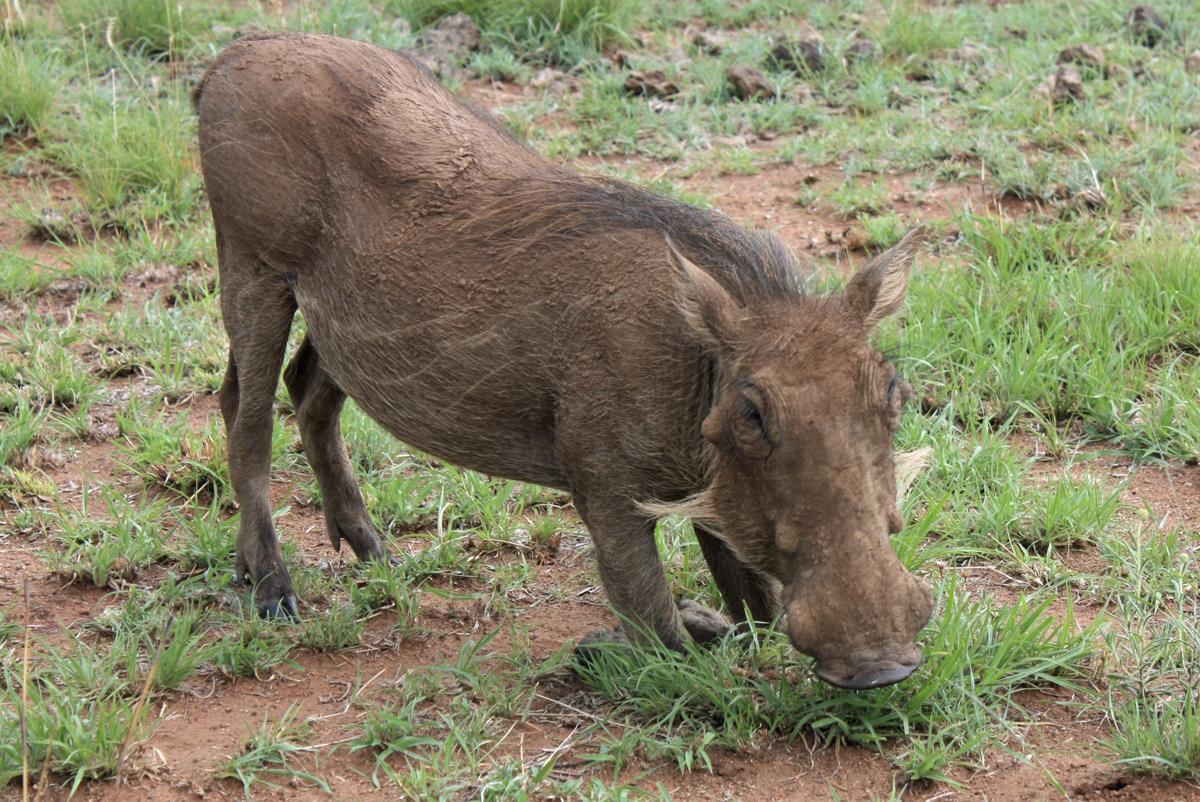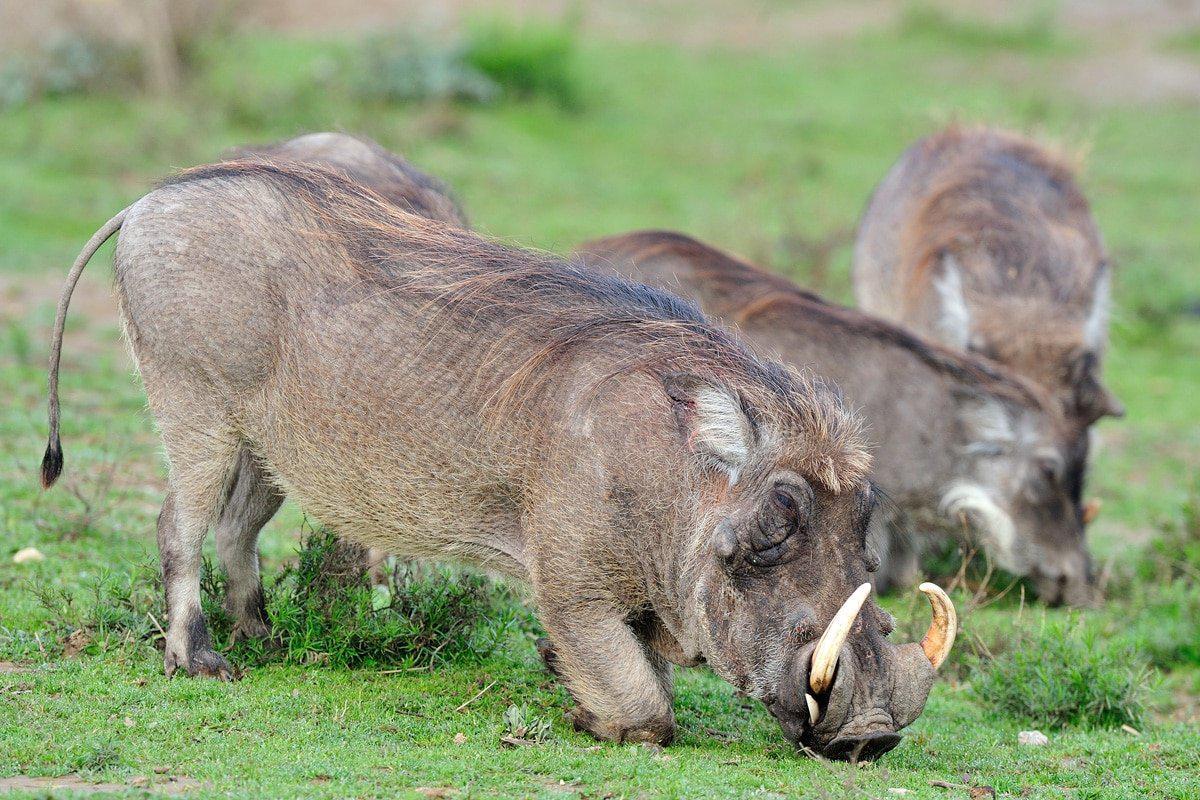The first image is the image on the left, the second image is the image on the right. Given the left and right images, does the statement "The animals in the image on the right are eating grass." hold true? Answer yes or no. Yes. 